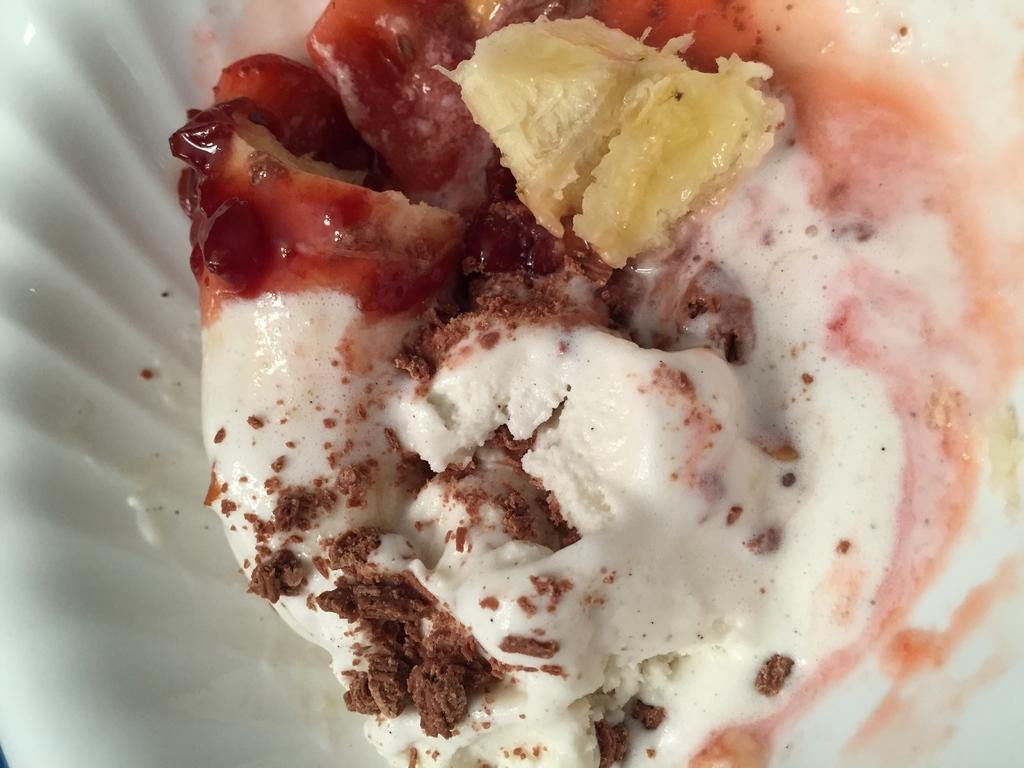What is the main subject of the image? There is a food item in the image. Can you describe the surface on which the food item is placed? The food item is on a white surface. What type of help can be seen in the image? There is no help visible in the image; it features a food item on a white surface. What kind of beetle is crawling on the food item in the image? There is no beetle present in the image. 